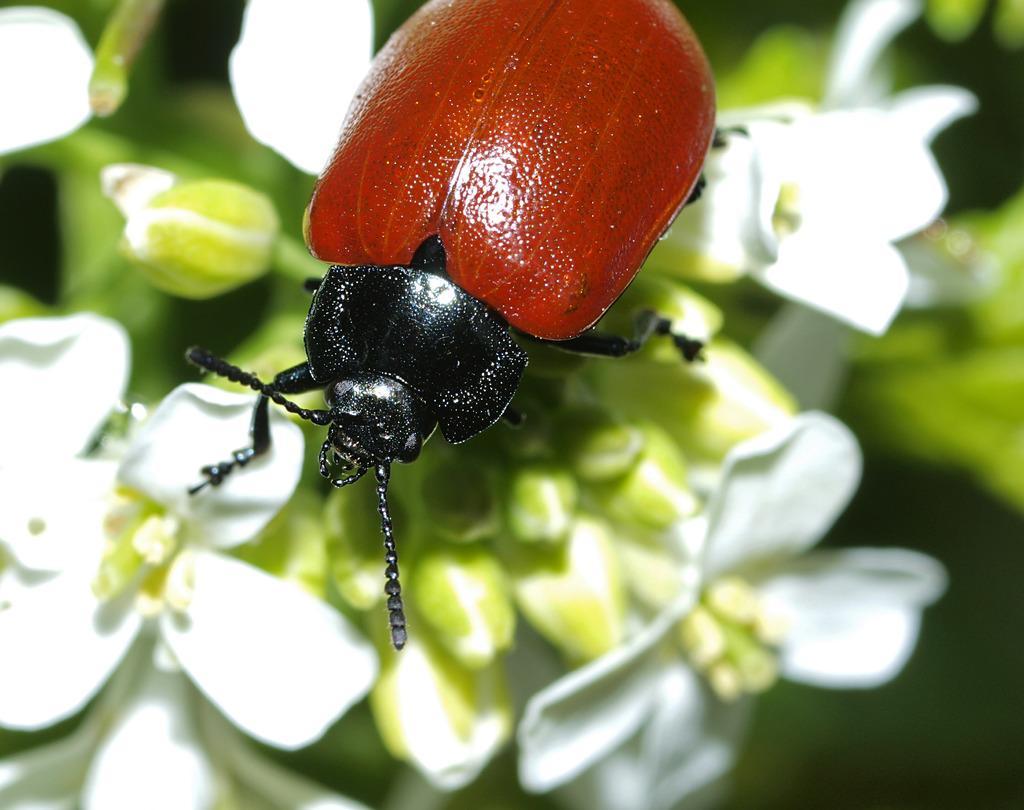Describe this image in one or two sentences. In this picture there is a beetle. The background is blurred. In the background there are flowers and leaves. 